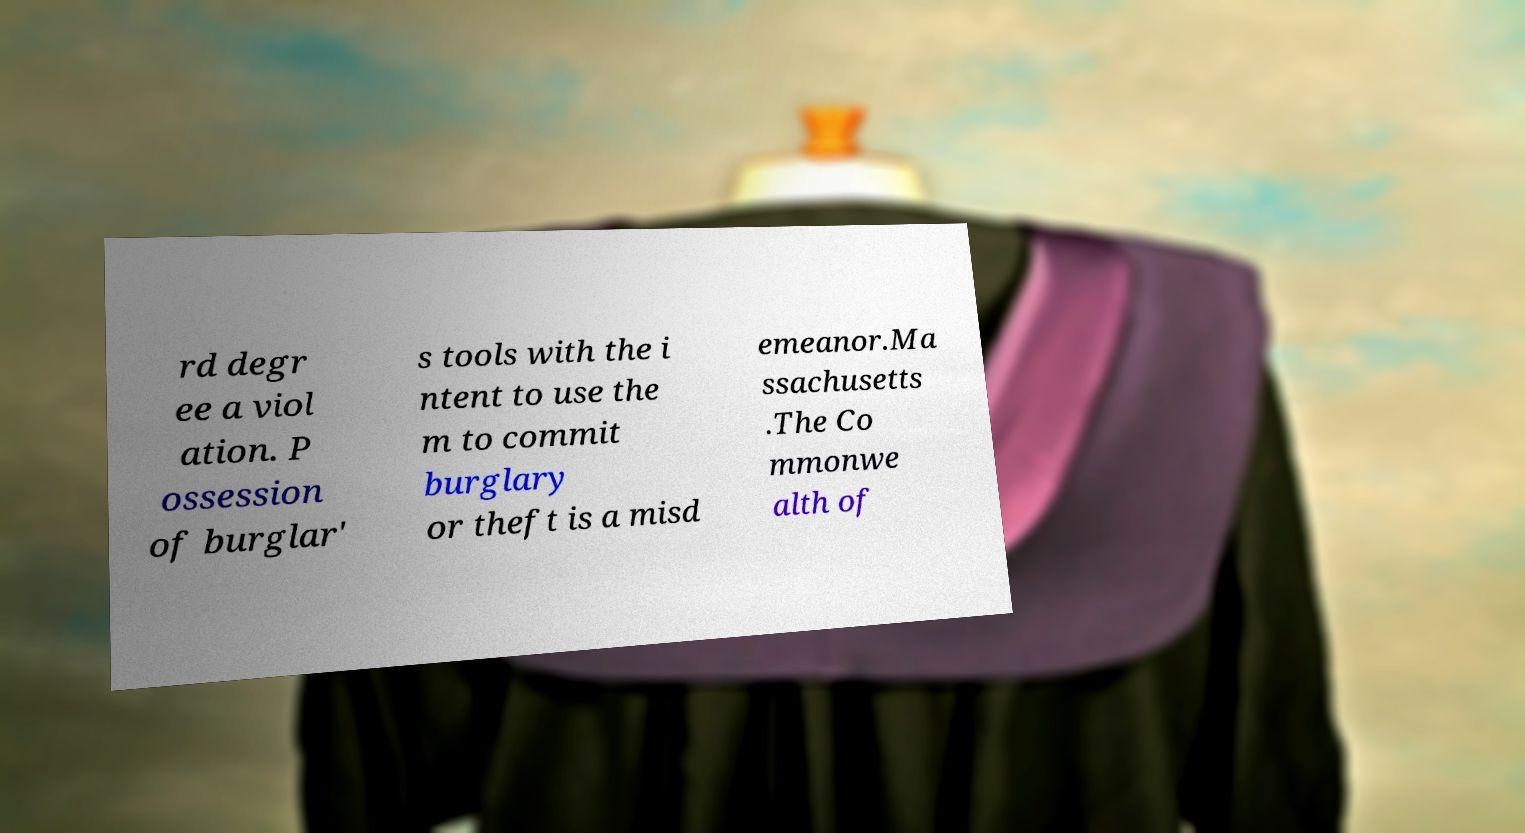There's text embedded in this image that I need extracted. Can you transcribe it verbatim? rd degr ee a viol ation. P ossession of burglar' s tools with the i ntent to use the m to commit burglary or theft is a misd emeanor.Ma ssachusetts .The Co mmonwe alth of 